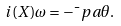<formula> <loc_0><loc_0><loc_500><loc_500>i ( X ) \omega = - \bar { \ } p a \theta .</formula> 